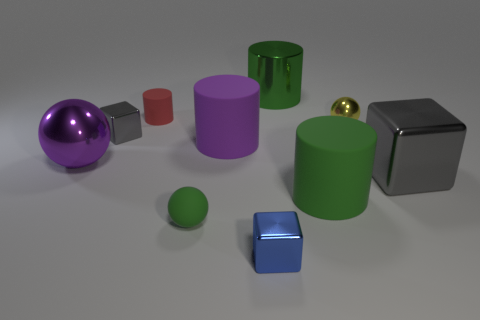Do the small shiny object left of the large purple rubber object and the gray thing that is right of the large purple cylinder have the same shape?
Ensure brevity in your answer.  Yes. There is a large object behind the large purple thing behind the big sphere; what is its color?
Give a very brief answer. Green. What number of cubes are either small objects or small blue metallic things?
Keep it short and to the point. 2. How many tiny spheres are in front of the gray metallic thing that is on the right side of the big object behind the small gray block?
Provide a short and direct response. 1. There is a ball that is the same color as the big metal cylinder; what is its size?
Provide a short and direct response. Small. Is there a large object that has the same material as the blue cube?
Keep it short and to the point. Yes. Are the large block and the tiny red cylinder made of the same material?
Give a very brief answer. No. What number of large gray blocks are left of the large matte object on the right side of the shiny cylinder?
Provide a short and direct response. 0. What number of red objects are either rubber objects or spheres?
Provide a succinct answer. 1. The gray thing that is on the left side of the gray cube that is on the right side of the metallic thing behind the red rubber cylinder is what shape?
Offer a very short reply. Cube. 